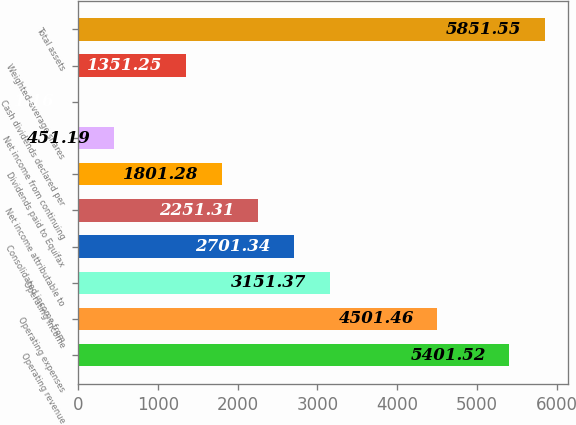<chart> <loc_0><loc_0><loc_500><loc_500><bar_chart><fcel>Operating revenue<fcel>Operating expenses<fcel>Operating income<fcel>Consolidated income from<fcel>Net income attributable to<fcel>Dividends paid to Equifax<fcel>Net income from continuing<fcel>Cash dividends declared per<fcel>Weighted-average shares<fcel>Total assets<nl><fcel>5401.52<fcel>4501.46<fcel>3151.37<fcel>2701.34<fcel>2251.31<fcel>1801.28<fcel>451.19<fcel>1.16<fcel>1351.25<fcel>5851.55<nl></chart> 